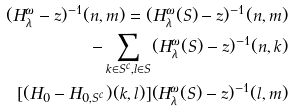<formula> <loc_0><loc_0><loc_500><loc_500>( H _ { \lambda } ^ { \omega } - z ) ^ { - 1 } ( n , m ) = ( H _ { \lambda } ^ { \omega } ( S ) - z ) ^ { - 1 } ( n , m ) \\ - \sum _ { k \in S ^ { c } , l \in S } ( H _ { \lambda } ^ { \omega } ( S ) - z ) ^ { - 1 } ( n , k ) \\ [ ( H _ { 0 } - H _ { 0 , S ^ { c } } ) ( k , l ) ] ( H _ { \lambda } ^ { \omega } ( S ) - z ) ^ { - 1 } ( l , m )</formula> 